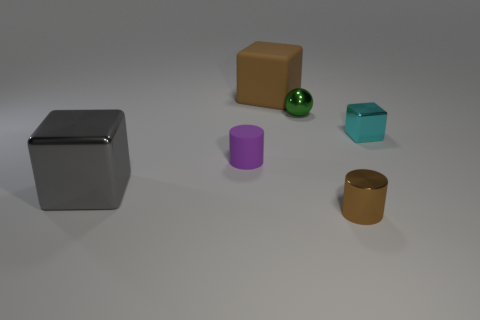Is the number of big balls less than the number of green spheres?
Keep it short and to the point. Yes. There is a shiny block left of the green metal ball; is it the same color as the rubber cube?
Your answer should be compact. No. The small sphere that is the same material as the small block is what color?
Offer a very short reply. Green. Is the purple matte object the same size as the rubber block?
Your answer should be compact. No. What material is the brown block?
Ensure brevity in your answer.  Rubber. What is the material of the cyan cube that is the same size as the purple rubber cylinder?
Make the answer very short. Metal. Are there any other cylinders that have the same size as the brown shiny cylinder?
Give a very brief answer. Yes. Is the number of brown things that are behind the tiny brown cylinder the same as the number of purple objects that are right of the tiny cyan cube?
Your answer should be compact. No. Is the number of tiny cyan metallic things greater than the number of gray matte blocks?
Your answer should be very brief. Yes. How many rubber objects are tiny brown objects or small cyan things?
Your answer should be very brief. 0. 